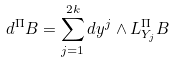<formula> <loc_0><loc_0><loc_500><loc_500>d ^ { \Pi } B = \sum _ { j = 1 } ^ { 2 k } d y ^ { j } \wedge L ^ { \Pi } _ { Y _ { j } } B</formula> 